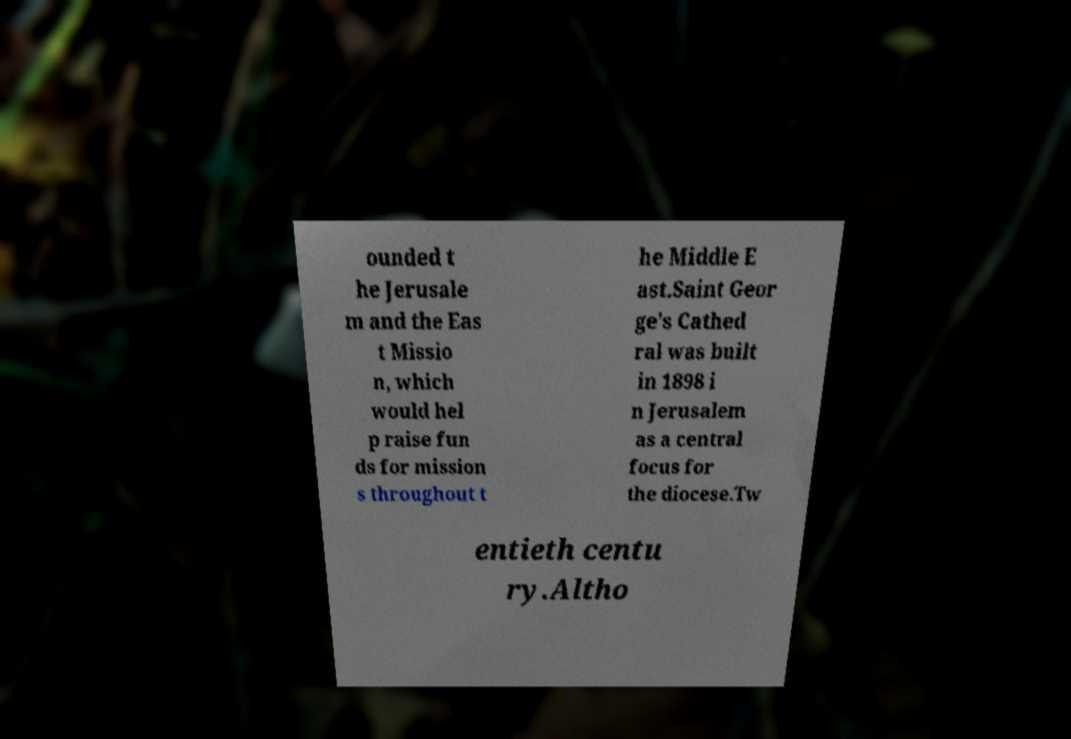Please identify and transcribe the text found in this image. ounded t he Jerusale m and the Eas t Missio n, which would hel p raise fun ds for mission s throughout t he Middle E ast.Saint Geor ge's Cathed ral was built in 1898 i n Jerusalem as a central focus for the diocese.Tw entieth centu ry.Altho 